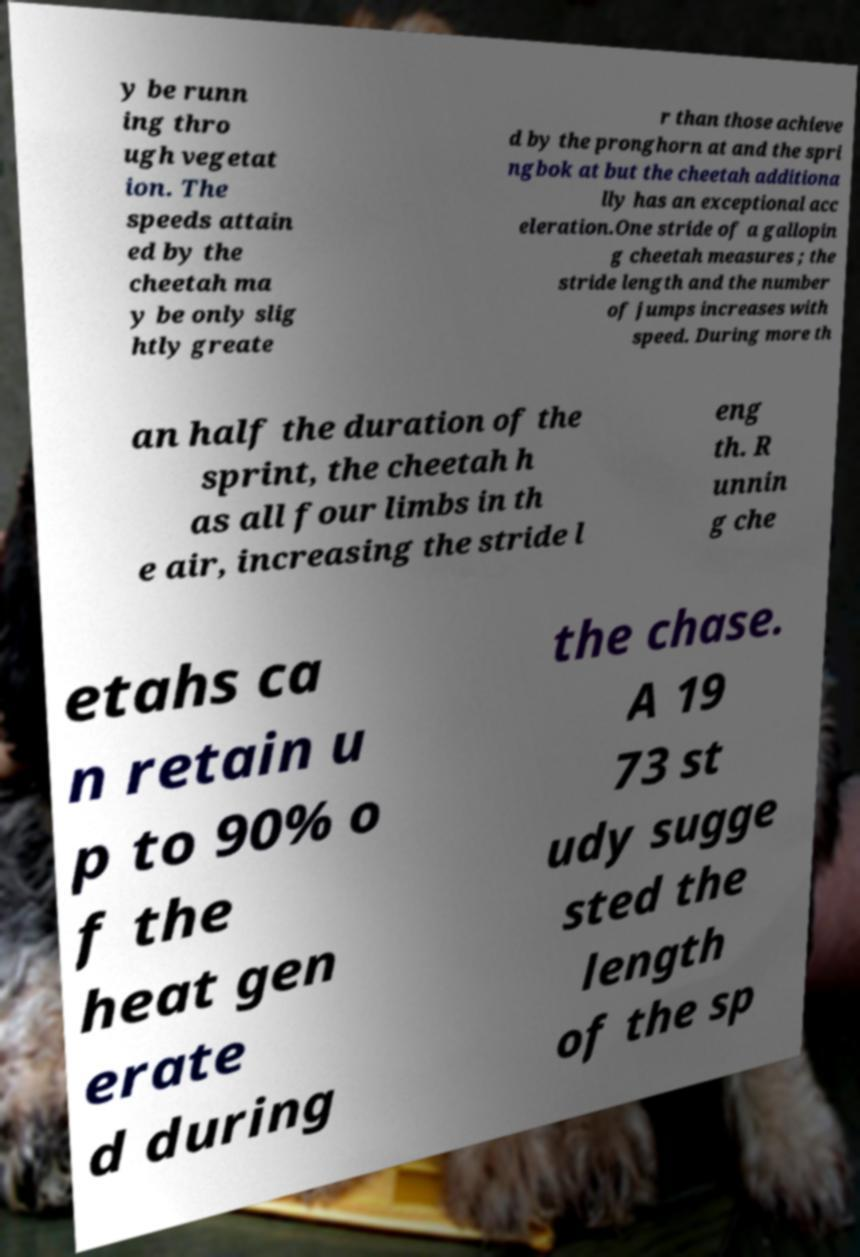What messages or text are displayed in this image? I need them in a readable, typed format. y be runn ing thro ugh vegetat ion. The speeds attain ed by the cheetah ma y be only slig htly greate r than those achieve d by the pronghorn at and the spri ngbok at but the cheetah additiona lly has an exceptional acc eleration.One stride of a gallopin g cheetah measures ; the stride length and the number of jumps increases with speed. During more th an half the duration of the sprint, the cheetah h as all four limbs in th e air, increasing the stride l eng th. R unnin g che etahs ca n retain u p to 90% o f the heat gen erate d during the chase. A 19 73 st udy sugge sted the length of the sp 